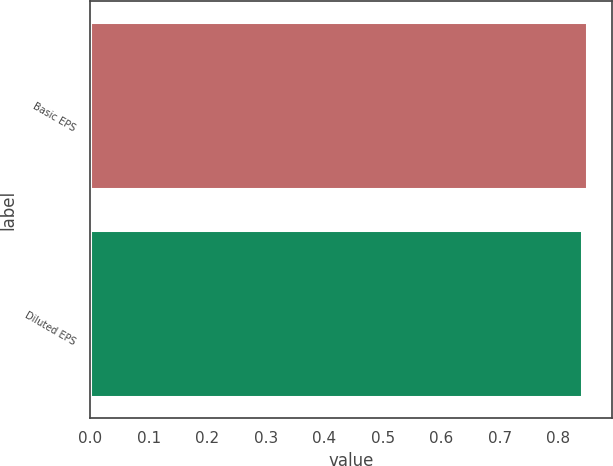<chart> <loc_0><loc_0><loc_500><loc_500><bar_chart><fcel>Basic EPS<fcel>Diluted EPS<nl><fcel>0.85<fcel>0.84<nl></chart> 